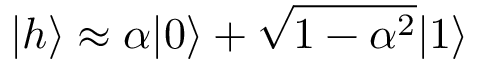Convert formula to latex. <formula><loc_0><loc_0><loc_500><loc_500>| h \rangle \approx \alpha | 0 \rangle + \sqrt { 1 - \alpha ^ { 2 } } | 1 \rangle</formula> 